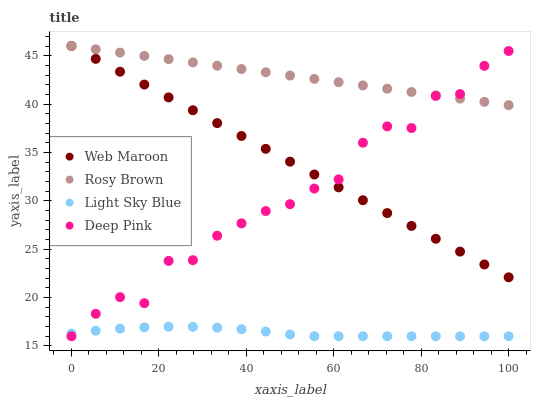Does Light Sky Blue have the minimum area under the curve?
Answer yes or no. Yes. Does Rosy Brown have the maximum area under the curve?
Answer yes or no. Yes. Does Web Maroon have the minimum area under the curve?
Answer yes or no. No. Does Web Maroon have the maximum area under the curve?
Answer yes or no. No. Is Web Maroon the smoothest?
Answer yes or no. Yes. Is Deep Pink the roughest?
Answer yes or no. Yes. Is Light Sky Blue the smoothest?
Answer yes or no. No. Is Light Sky Blue the roughest?
Answer yes or no. No. Does Light Sky Blue have the lowest value?
Answer yes or no. Yes. Does Web Maroon have the lowest value?
Answer yes or no. No. Does Web Maroon have the highest value?
Answer yes or no. Yes. Does Light Sky Blue have the highest value?
Answer yes or no. No. Is Light Sky Blue less than Rosy Brown?
Answer yes or no. Yes. Is Web Maroon greater than Light Sky Blue?
Answer yes or no. Yes. Does Web Maroon intersect Deep Pink?
Answer yes or no. Yes. Is Web Maroon less than Deep Pink?
Answer yes or no. No. Is Web Maroon greater than Deep Pink?
Answer yes or no. No. Does Light Sky Blue intersect Rosy Brown?
Answer yes or no. No. 